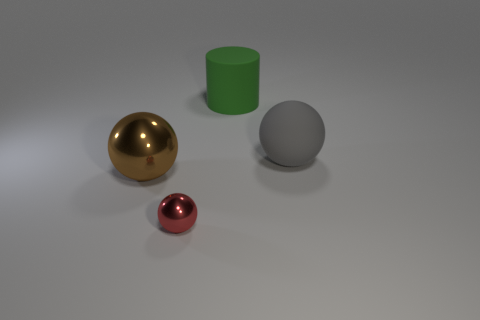Is the number of big green matte cylinders that are in front of the matte ball greater than the number of matte things?
Give a very brief answer. No. How many green things have the same size as the red sphere?
Make the answer very short. 0. There is a metallic object that is behind the tiny metallic sphere; is its size the same as the thing that is behind the big matte ball?
Provide a short and direct response. Yes. Is the number of small red objects to the right of the green rubber object greater than the number of tiny things behind the large shiny ball?
Offer a terse response. No. How many big gray matte things are the same shape as the green rubber thing?
Offer a very short reply. 0. There is another sphere that is the same size as the brown sphere; what is its material?
Your answer should be very brief. Rubber. Is there a green sphere that has the same material as the green cylinder?
Your response must be concise. No. Is the number of brown things behind the green object less than the number of green rubber cylinders?
Make the answer very short. Yes. What material is the large gray thing behind the shiny ball that is on the left side of the small red shiny thing?
Make the answer very short. Rubber. There is a object that is both behind the tiny shiny object and in front of the gray ball; what is its shape?
Give a very brief answer. Sphere. 